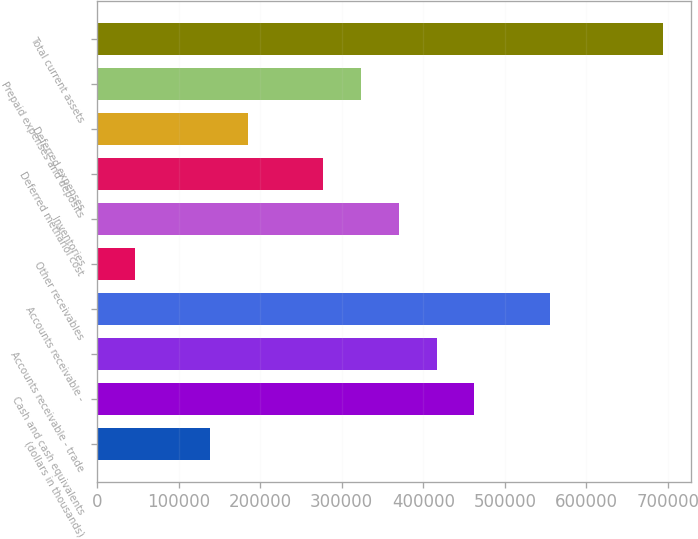Convert chart. <chart><loc_0><loc_0><loc_500><loc_500><bar_chart><fcel>(dollars in thousands)<fcel>Cash and cash equivalents<fcel>Accounts receivable - trade<fcel>Accounts receivable -<fcel>Other receivables<fcel>Inventories<fcel>Deferred methanol cost<fcel>Deferred expenses<fcel>Prepaid expenses and deposits<fcel>Total current assets<nl><fcel>139042<fcel>462459<fcel>416256<fcel>554864<fcel>46636.5<fcel>370054<fcel>277649<fcel>185244<fcel>323852<fcel>693472<nl></chart> 